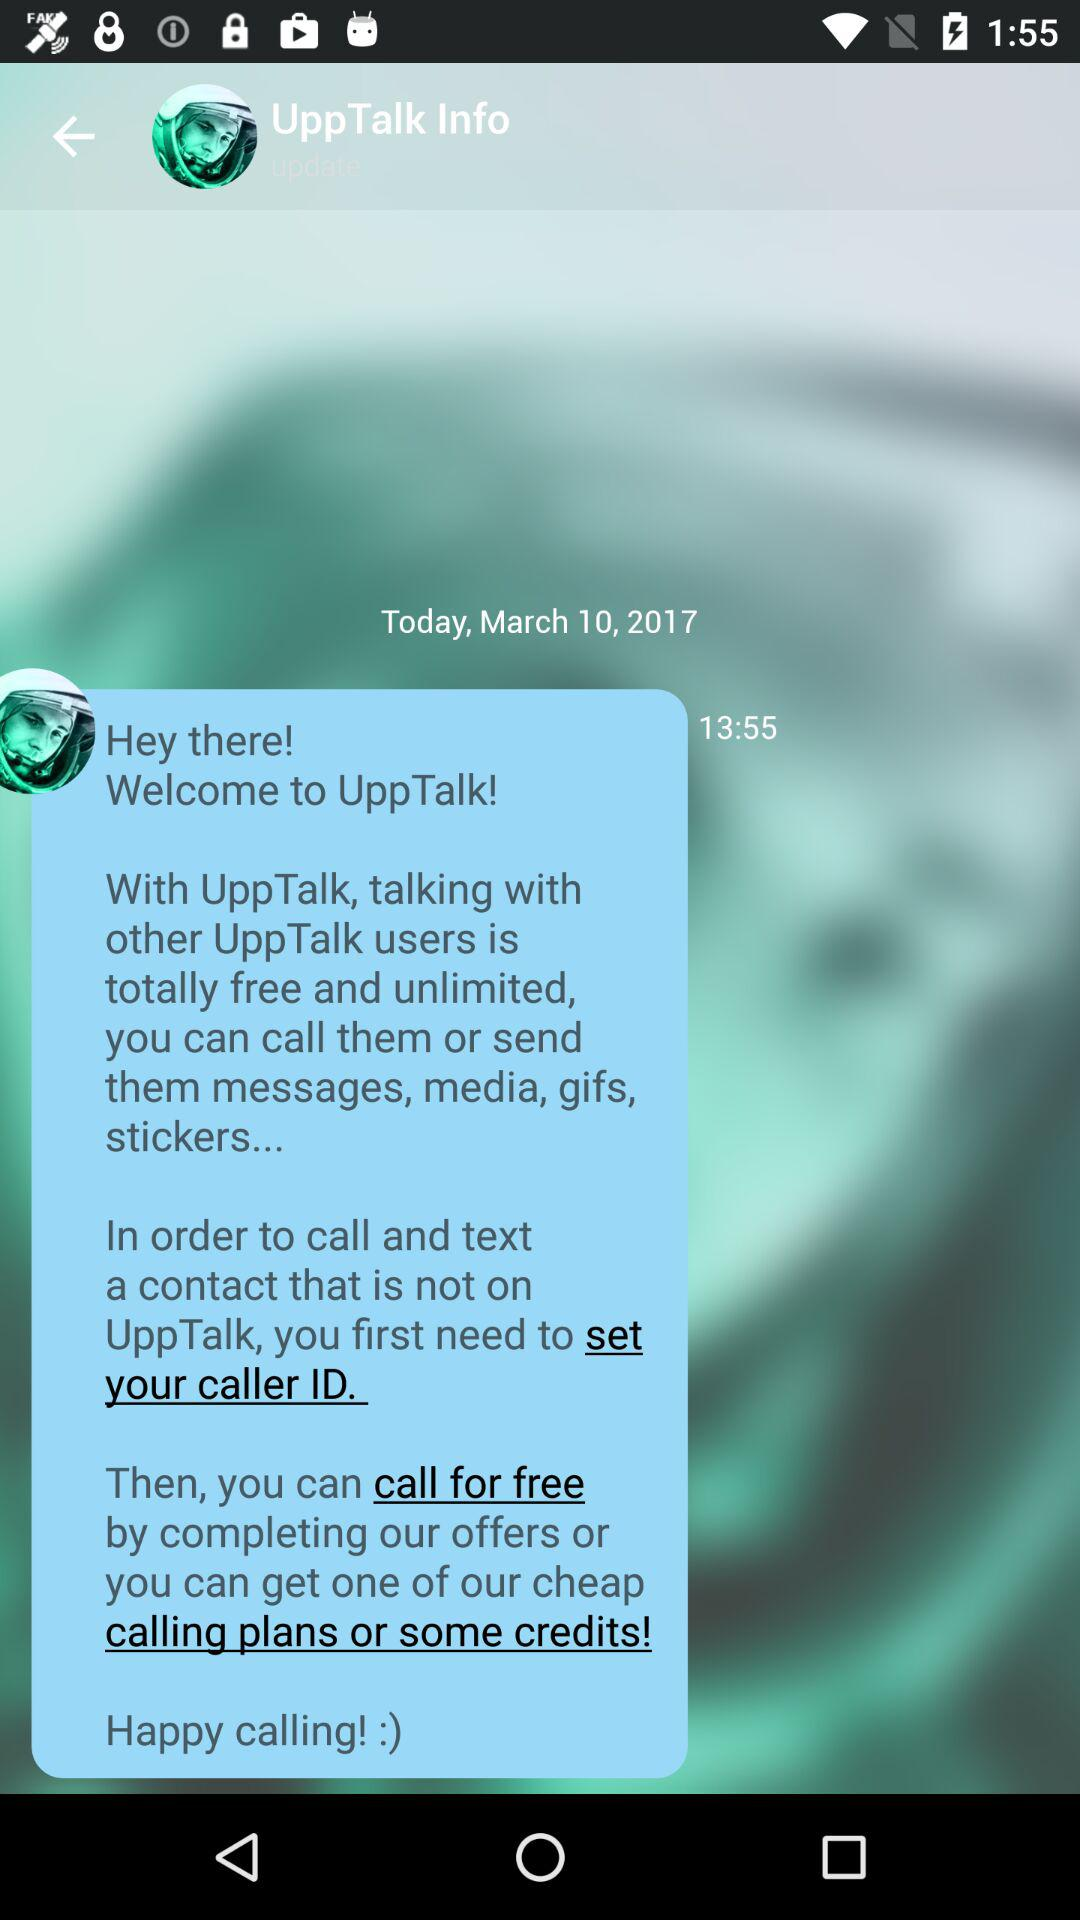At what time was the message received? The message was received at 13:55. 